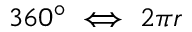Convert formula to latex. <formula><loc_0><loc_0><loc_500><loc_500>3 6 0 ^ { \circ } \iff 2 \pi r</formula> 